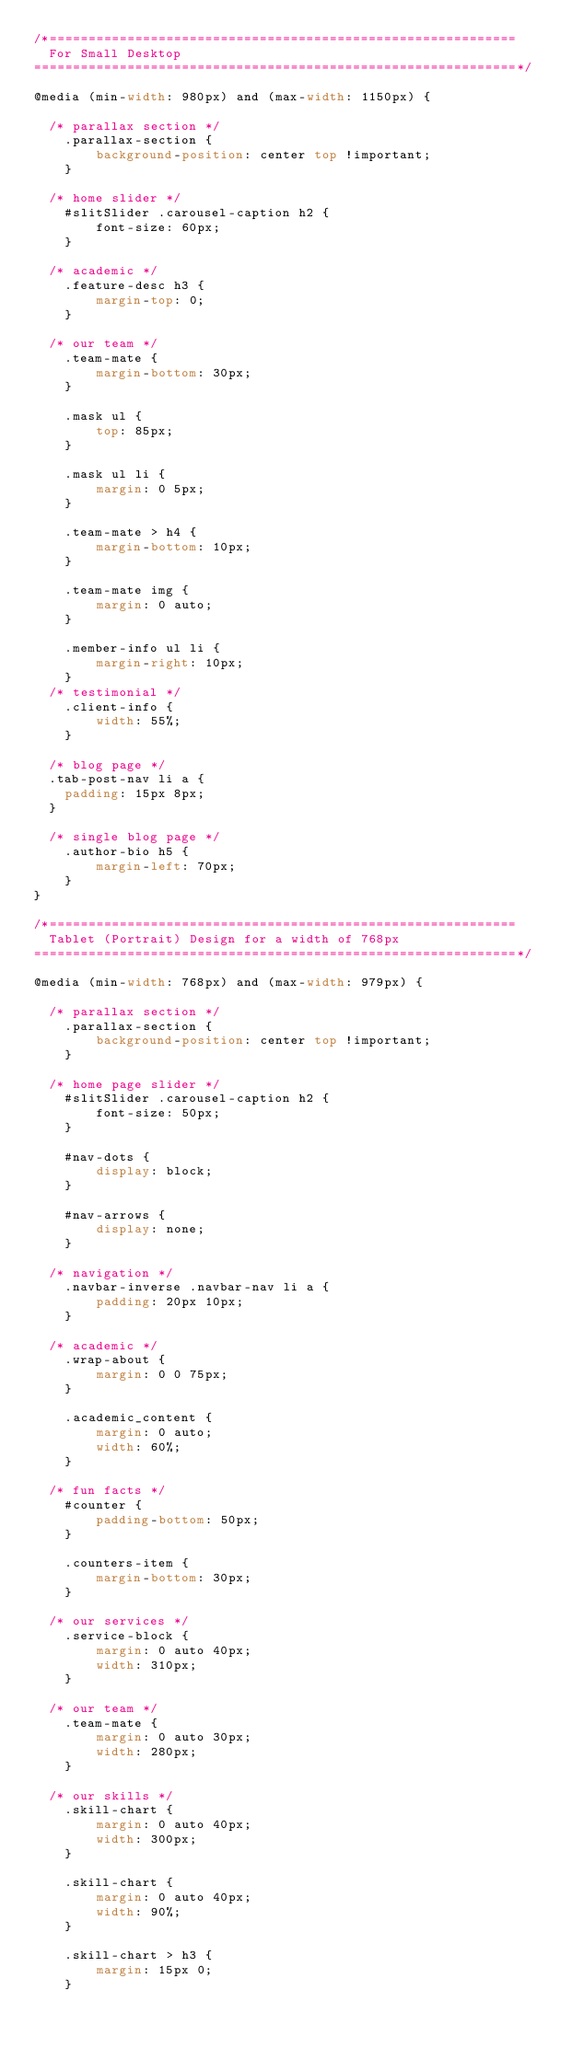Convert code to text. <code><loc_0><loc_0><loc_500><loc_500><_CSS_>/*============================================================
	For Small Desktop
==============================================================*/

@media (min-width: 980px) and (max-width: 1150px) {

	/* parallax section */
    .parallax-section {
        background-position: center top !important;
    }
	
	/* home slider */
    #slitSlider .carousel-caption h2 {
        font-size: 60px;
    }
	
	/* academic */
    .feature-desc h3 {
        margin-top: 0;
    }
	
	/* our team */
    .team-mate {
        margin-bottom: 30px;
    }

    .mask ul {
        top: 85px;
    }

    .mask ul li {
        margin: 0 5px;
    }

    .team-mate > h4 {
        margin-bottom: 10px;
    }

    .team-mate img {
        margin: 0 auto;
    }

    .member-info ul li {
        margin-right: 10px;
    }
	/* testimonial */
    .client-info {
        width: 55%;
    }
	
	/* blog page */
	.tab-post-nav li a {
		padding: 15px 8px;
	}
	
	/* single blog page */
    .author-bio h5 {
        margin-left: 70px;
    }
}

/*============================================================
	Tablet (Portrait) Design for a width of 768px
==============================================================*/

@media (min-width: 768px) and (max-width: 979px) {

	/* parallax section */
    .parallax-section {
        background-position: center top !important;
    }

	/* home page slider */
    #slitSlider .carousel-caption h2 {
        font-size: 50px;
    }

    #nav-dots {
        display: block;
    }

    #nav-arrows {
        display: none;
    }
	
	/* navigation */
    .navbar-inverse .navbar-nav li a {
        padding: 20px 10px;
    }

	/* academic */
    .wrap-about {
        margin: 0 0 75px;
    }

    .academic_content {
        margin: 0 auto;
        width: 60%;
    }

	/* fun facts */
    #counter {
        padding-bottom: 50px;
    }

    .counters-item {
        margin-bottom: 30px;
    }

	/* our services */
    .service-block {
        margin: 0 auto 40px;
        width: 310px;
    }

	/* our team */
    .team-mate {
        margin: 0 auto 30px;
        width: 280px;
    }

	/* our skills */
    .skill-chart {
        margin: 0 auto 40px;
        width: 300px;
    }

    .skill-chart {
        margin: 0 auto 40px;
        width: 90%;
    }

    .skill-chart > h3 {
        margin: 15px 0;
    }
</code> 